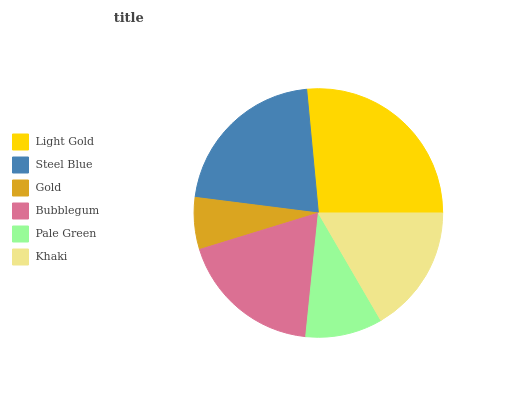Is Gold the minimum?
Answer yes or no. Yes. Is Light Gold the maximum?
Answer yes or no. Yes. Is Steel Blue the minimum?
Answer yes or no. No. Is Steel Blue the maximum?
Answer yes or no. No. Is Light Gold greater than Steel Blue?
Answer yes or no. Yes. Is Steel Blue less than Light Gold?
Answer yes or no. Yes. Is Steel Blue greater than Light Gold?
Answer yes or no. No. Is Light Gold less than Steel Blue?
Answer yes or no. No. Is Bubblegum the high median?
Answer yes or no. Yes. Is Khaki the low median?
Answer yes or no. Yes. Is Light Gold the high median?
Answer yes or no. No. Is Light Gold the low median?
Answer yes or no. No. 